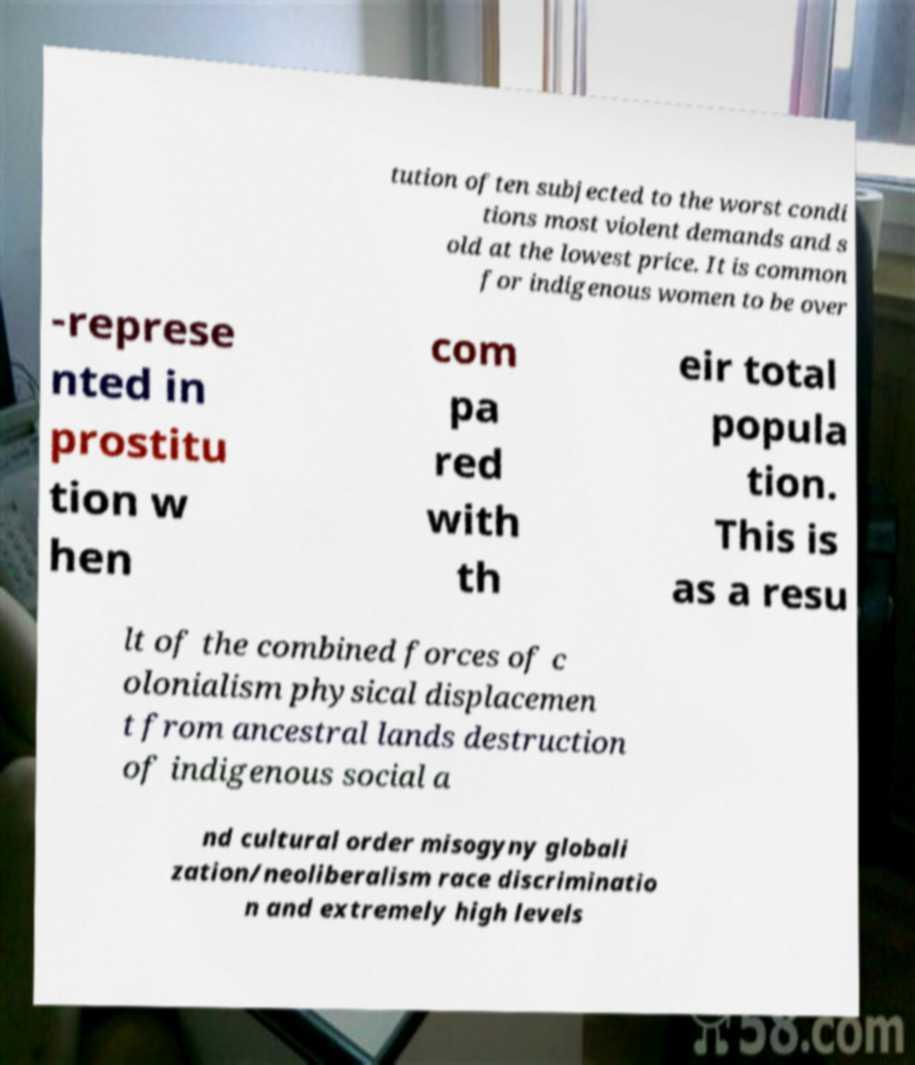Could you assist in decoding the text presented in this image and type it out clearly? tution often subjected to the worst condi tions most violent demands and s old at the lowest price. It is common for indigenous women to be over -represe nted in prostitu tion w hen com pa red with th eir total popula tion. This is as a resu lt of the combined forces of c olonialism physical displacemen t from ancestral lands destruction of indigenous social a nd cultural order misogyny globali zation/neoliberalism race discriminatio n and extremely high levels 